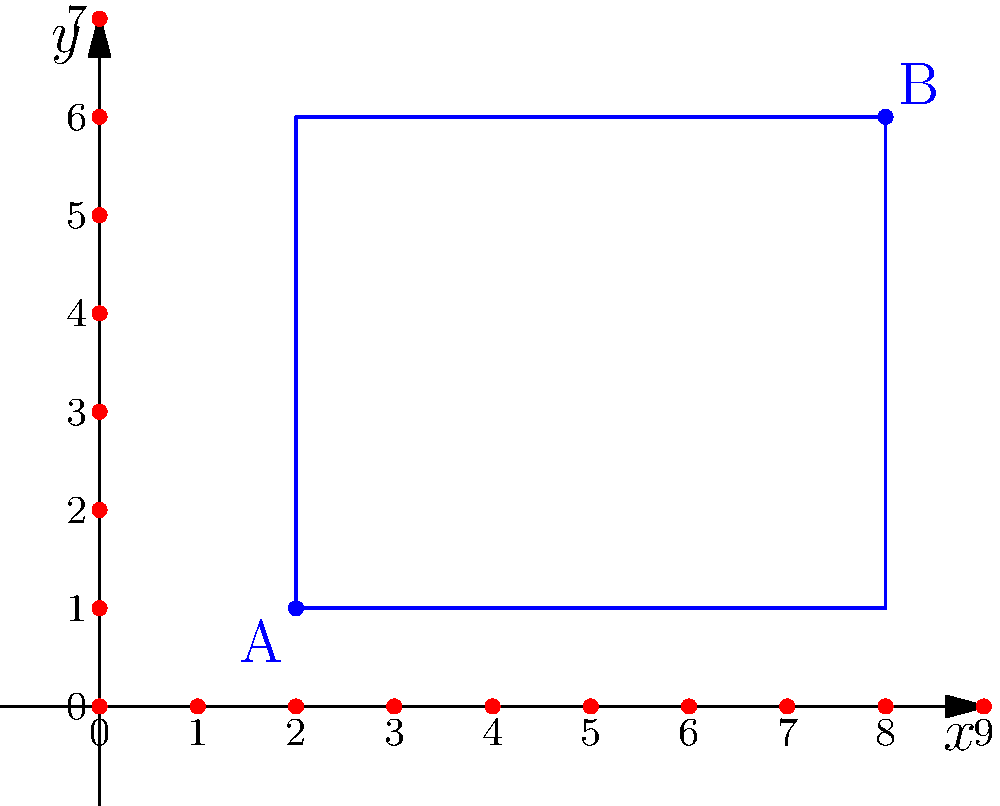You're planning a small garden in your backyard to grow vegetables for your family. The garden plot is rectangular, and you've marked its opposite corners on a coordinate grid. Point A is at (2, 1), and point B is at (8, 6). What is the area of your garden plot in square units? Let's approach this step-by-step:

1) To find the area of a rectangle, we need its length and width.

2) The coordinates of the opposite corners are:
   A(2, 1) and B(8, 6)

3) To find the length:
   - The x-coordinates differ by: 8 - 2 = 6 units

4) To find the width:
   - The y-coordinates differ by: 6 - 1 = 5 units

5) Now we have a rectangle with:
   - Length = 6 units
   - Width = 5 units

6) The area of a rectangle is given by the formula:
   $$ \text{Area} = \text{length} \times \text{width} $$

7) Plugging in our values:
   $$ \text{Area} = 6 \times 5 = 30 $$

Therefore, the area of your garden plot is 30 square units.
Answer: 30 square units 